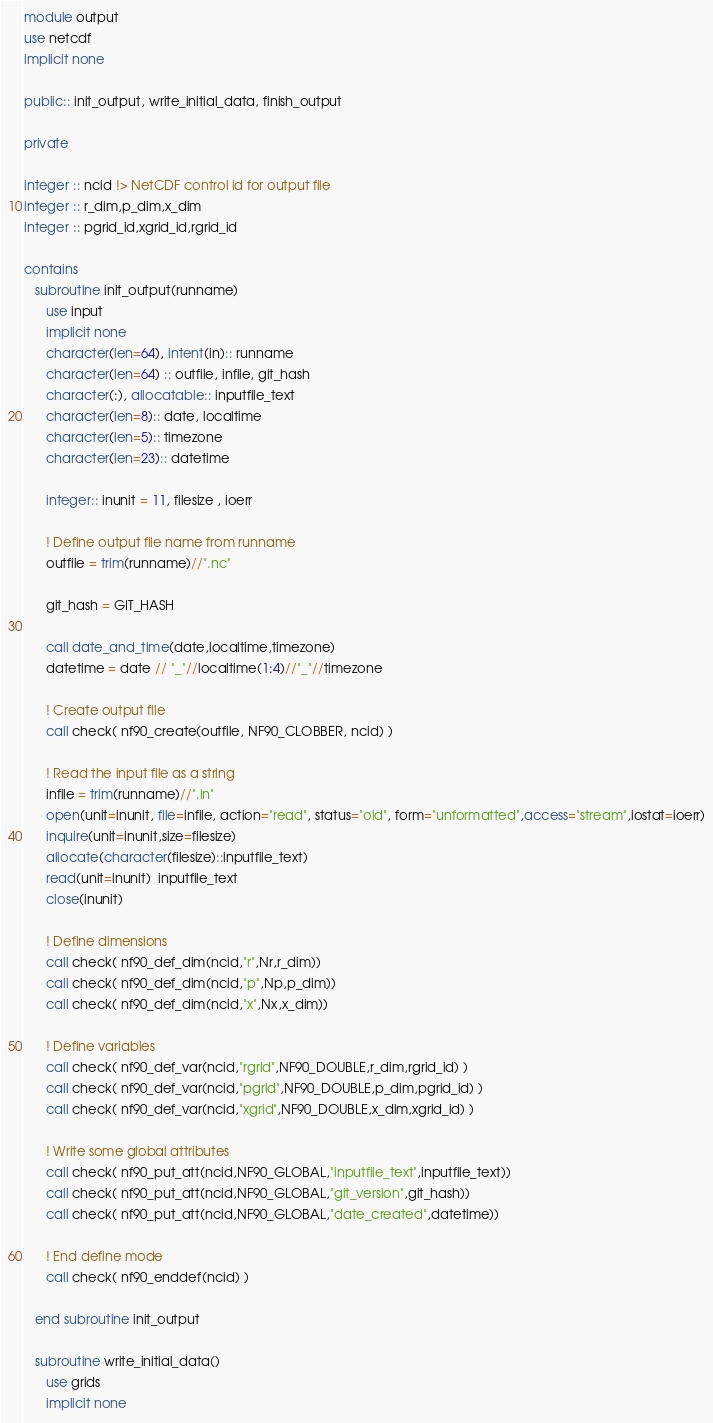Convert code to text. <code><loc_0><loc_0><loc_500><loc_500><_FORTRAN_>module output
use netcdf
implicit none

public:: init_output, write_initial_data, finish_output

private

integer :: ncid !> NetCDF control id for output file
integer :: r_dim,p_dim,x_dim
integer :: pgrid_id,xgrid_id,rgrid_id

contains
   subroutine init_output(runname)
      use input
      implicit none
      character(len=64), intent(in):: runname
      character(len=64) :: outfile, infile, git_hash
      character(:), allocatable:: inputfile_text
      character(len=8):: date, localtime
      character(len=5):: timezone
      character(len=23):: datetime

      integer:: inunit = 11, filesize , ioerr

      ! Define output file name from runname
      outfile = trim(runname)//".nc"

      git_hash = GIT_HASH

      call date_and_time(date,localtime,timezone)
      datetime = date // "_"//localtime(1:4)//"_"//timezone

      ! Create output file
      call check( nf90_create(outfile, NF90_CLOBBER, ncid) )

      ! Read the input file as a string
      infile = trim(runname)//".in"
      open(unit=inunit, file=infile, action="read", status="old", form="unformatted",access="stream",iostat=ioerr)
      inquire(unit=inunit,size=filesize)
      allocate(character(filesize)::inputfile_text)
      read(unit=inunit)  inputfile_text
      close(inunit)

      ! Define dimensions
      call check( nf90_def_dim(ncid,"r",Nr,r_dim))
      call check( nf90_def_dim(ncid,"p",Np,p_dim))
      call check( nf90_def_dim(ncid,"x",Nx,x_dim))

      ! Define variables
      call check( nf90_def_var(ncid,"rgrid",NF90_DOUBLE,r_dim,rgrid_id) )
      call check( nf90_def_var(ncid,"pgrid",NF90_DOUBLE,p_dim,pgrid_id) )
      call check( nf90_def_var(ncid,"xgrid",NF90_DOUBLE,x_dim,xgrid_id) )

      ! Write some global attributes
      call check( nf90_put_att(ncid,NF90_GLOBAL,"inputfile_text",inputfile_text))
      call check( nf90_put_att(ncid,NF90_GLOBAL,"git_version",git_hash))
      call check( nf90_put_att(ncid,NF90_GLOBAL,"date_created",datetime))

      ! End define mode
      call check( nf90_enddef(ncid) )

   end subroutine init_output

   subroutine write_initial_data()
      use grids
      implicit none
</code> 